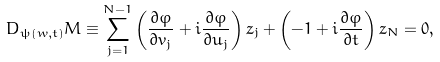<formula> <loc_0><loc_0><loc_500><loc_500>D _ { \psi ( w , t ) } M \equiv \sum _ { j = 1 } ^ { N - 1 } \left ( \frac { \partial \varphi } { \partial v _ { j } } + i \frac { \partial \varphi } { \partial u _ { j } } \right ) z _ { j } + \left ( - 1 + i \frac { \partial \varphi } { \partial t } \right ) z _ { N } = 0 ,</formula> 